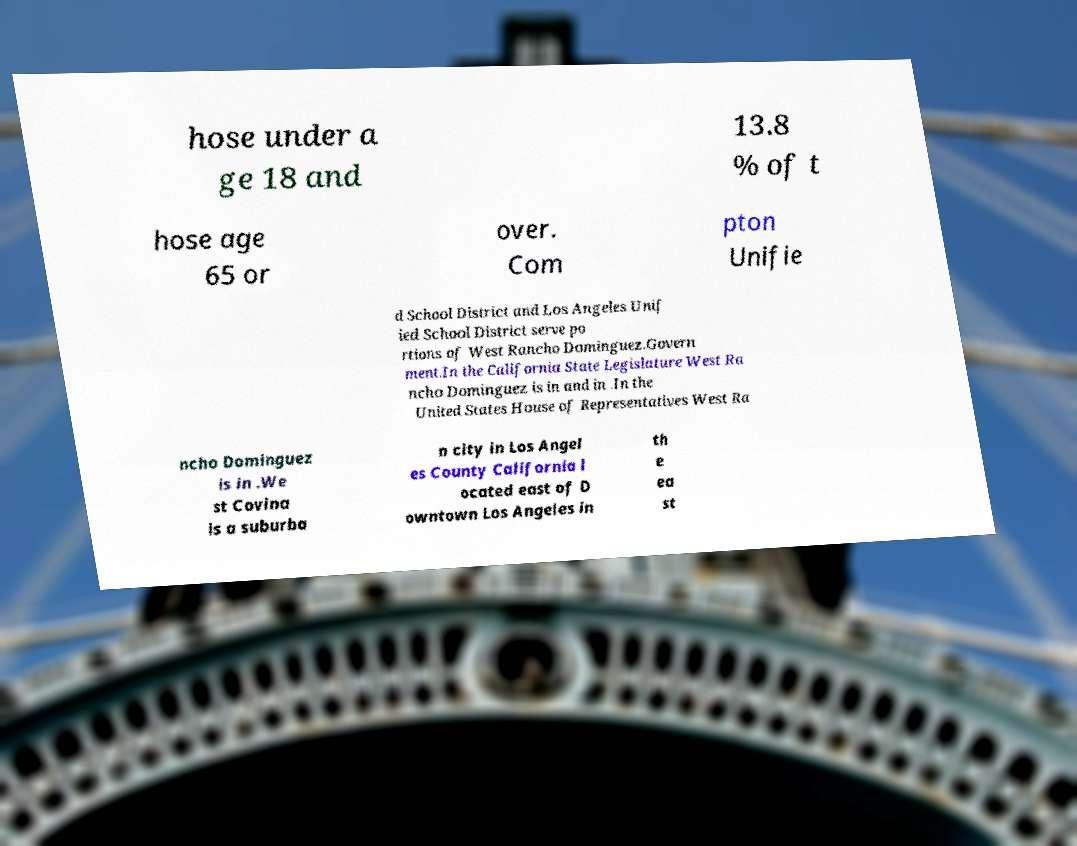Can you accurately transcribe the text from the provided image for me? hose under a ge 18 and 13.8 % of t hose age 65 or over. Com pton Unifie d School District and Los Angeles Unif ied School District serve po rtions of West Rancho Dominguez.Govern ment.In the California State Legislature West Ra ncho Dominguez is in and in .In the United States House of Representatives West Ra ncho Dominguez is in .We st Covina is a suburba n city in Los Angel es County California l ocated east of D owntown Los Angeles in th e ea st 